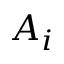<formula> <loc_0><loc_0><loc_500><loc_500>A _ { i }</formula> 